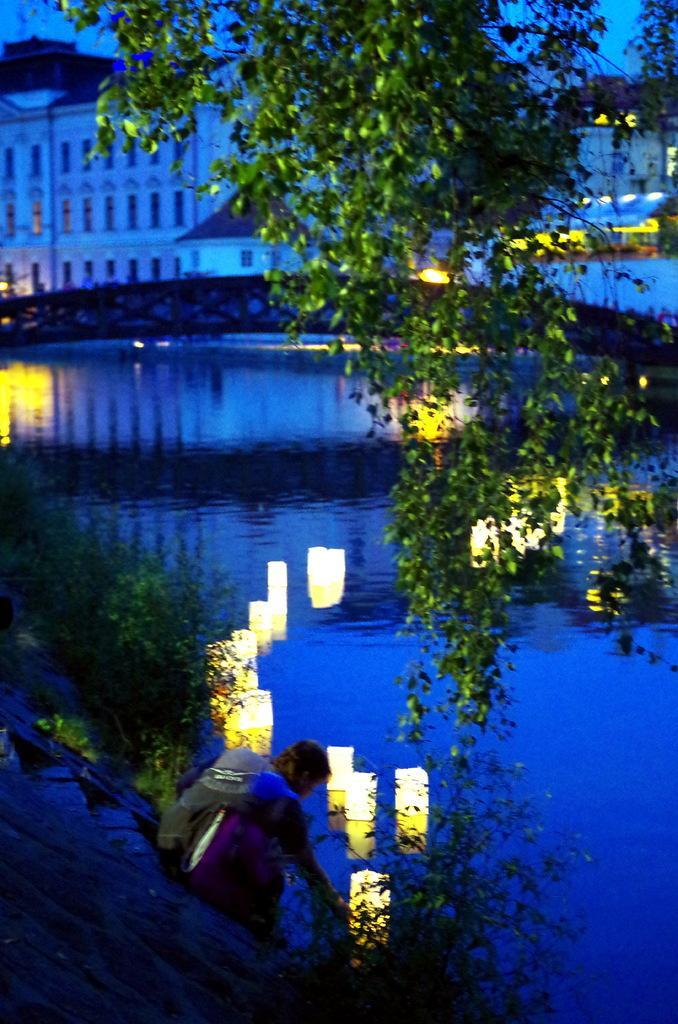How would you summarize this image in a sentence or two? In front of the image there are trees. There is a person sitting on the stairs. In front of her there are lamps in the water. There are plants. In the center of the image there is a bridge. In the background of the image there are buildings, lights. 